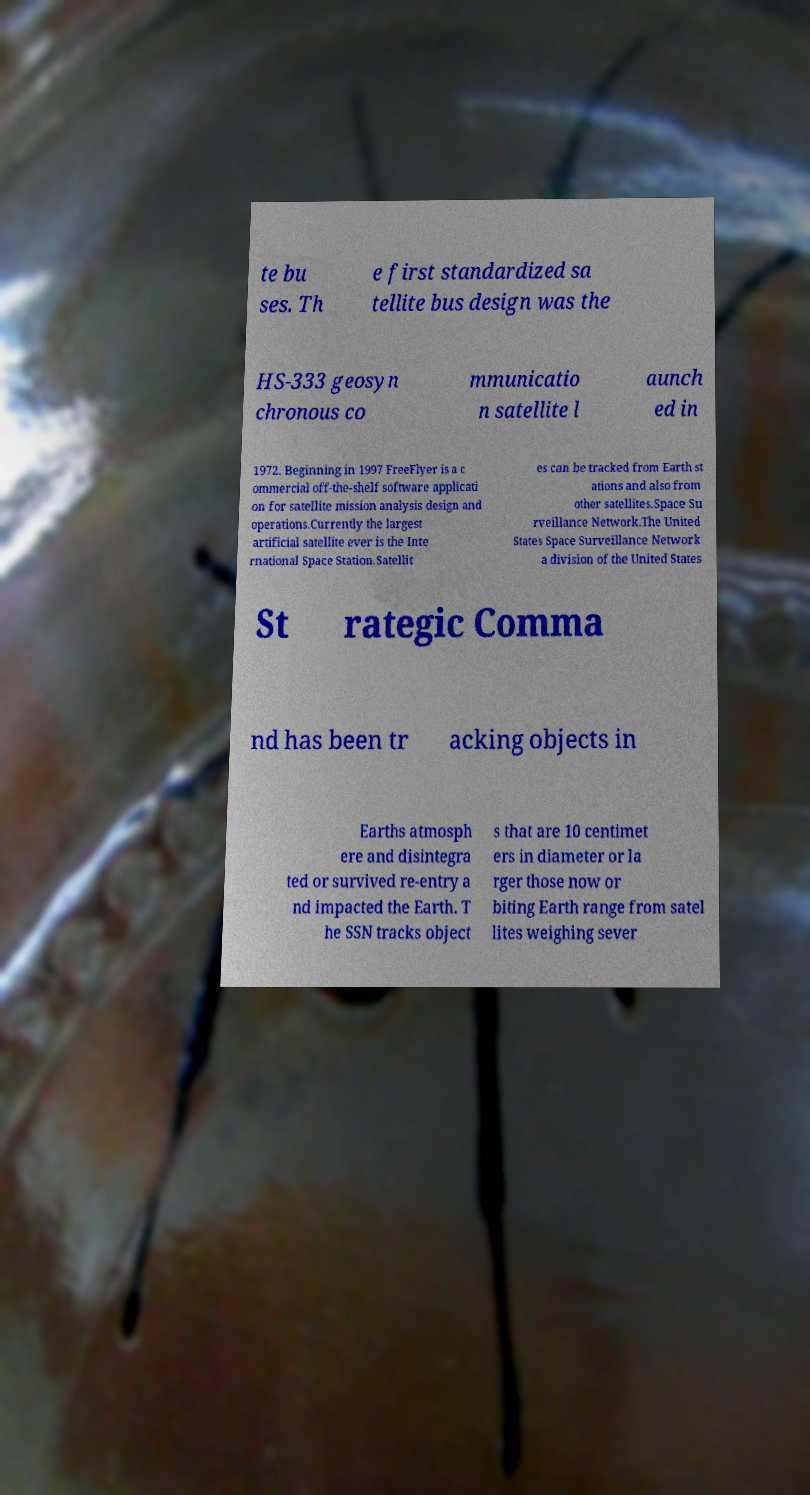For documentation purposes, I need the text within this image transcribed. Could you provide that? te bu ses. Th e first standardized sa tellite bus design was the HS-333 geosyn chronous co mmunicatio n satellite l aunch ed in 1972. Beginning in 1997 FreeFlyer is a c ommercial off-the-shelf software applicati on for satellite mission analysis design and operations.Currently the largest artificial satellite ever is the Inte rnational Space Station.Satellit es can be tracked from Earth st ations and also from other satellites.Space Su rveillance Network.The United States Space Surveillance Network a division of the United States St rategic Comma nd has been tr acking objects in Earths atmosph ere and disintegra ted or survived re-entry a nd impacted the Earth. T he SSN tracks object s that are 10 centimet ers in diameter or la rger those now or biting Earth range from satel lites weighing sever 